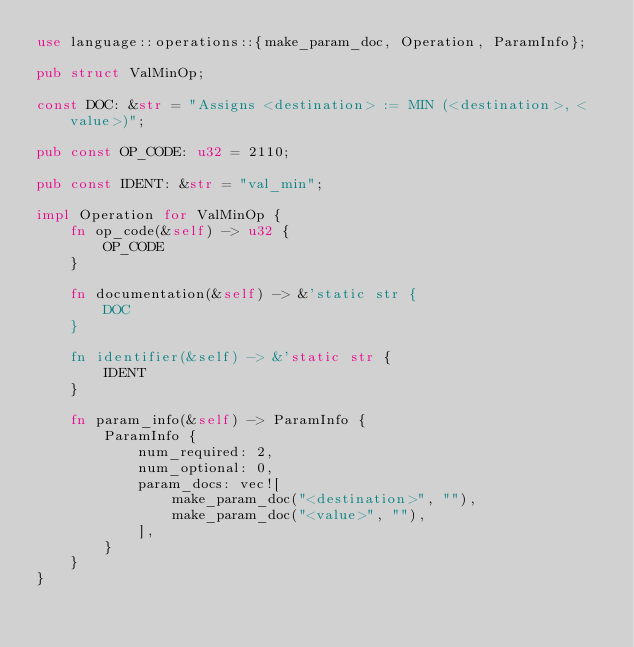Convert code to text. <code><loc_0><loc_0><loc_500><loc_500><_Rust_>use language::operations::{make_param_doc, Operation, ParamInfo};

pub struct ValMinOp;

const DOC: &str = "Assigns <destination> := MIN (<destination>, <value>)";

pub const OP_CODE: u32 = 2110;

pub const IDENT: &str = "val_min";

impl Operation for ValMinOp {
    fn op_code(&self) -> u32 {
        OP_CODE
    }

    fn documentation(&self) -> &'static str {
        DOC
    }

    fn identifier(&self) -> &'static str {
        IDENT
    }

    fn param_info(&self) -> ParamInfo {
        ParamInfo {
            num_required: 2,
            num_optional: 0,
            param_docs: vec![
                make_param_doc("<destination>", ""),
                make_param_doc("<value>", ""),
            ],
        }
    }
}
</code> 